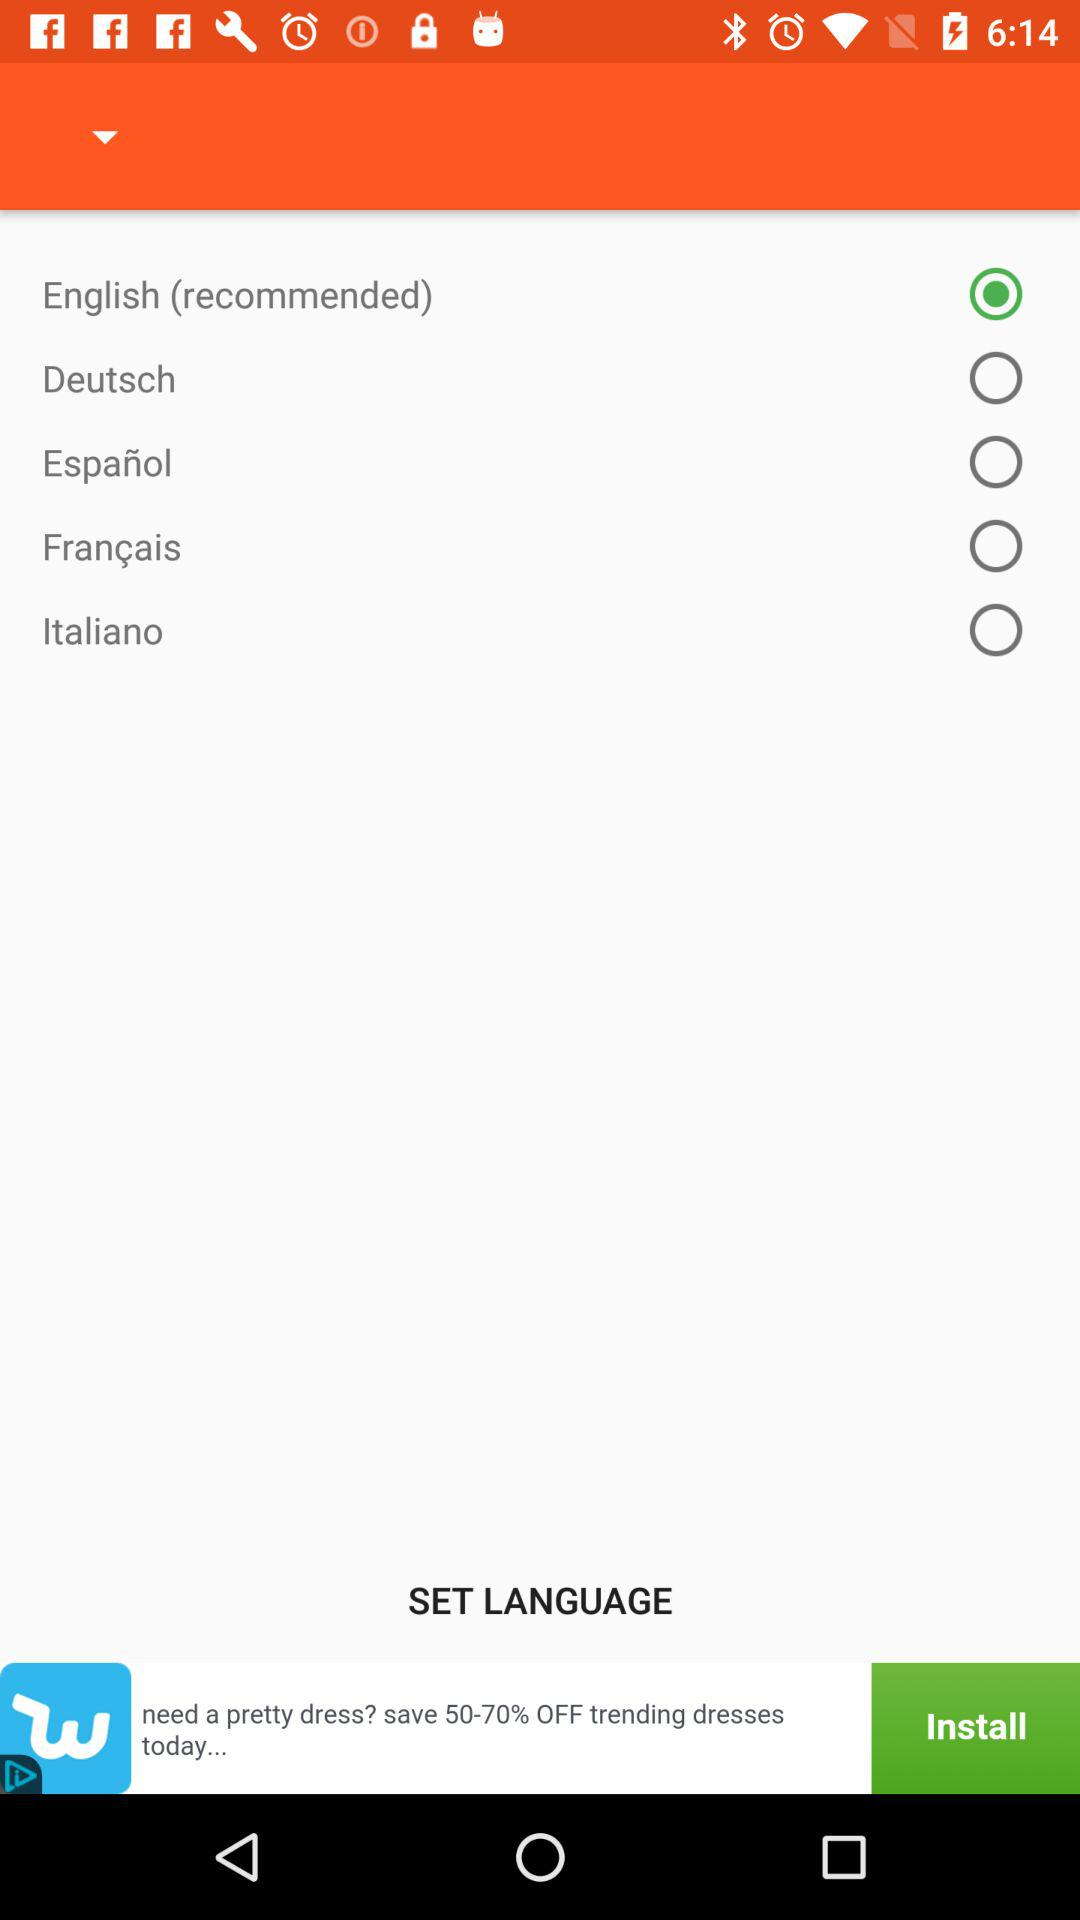How many languages are available in the language selection menu?
Answer the question using a single word or phrase. 5 